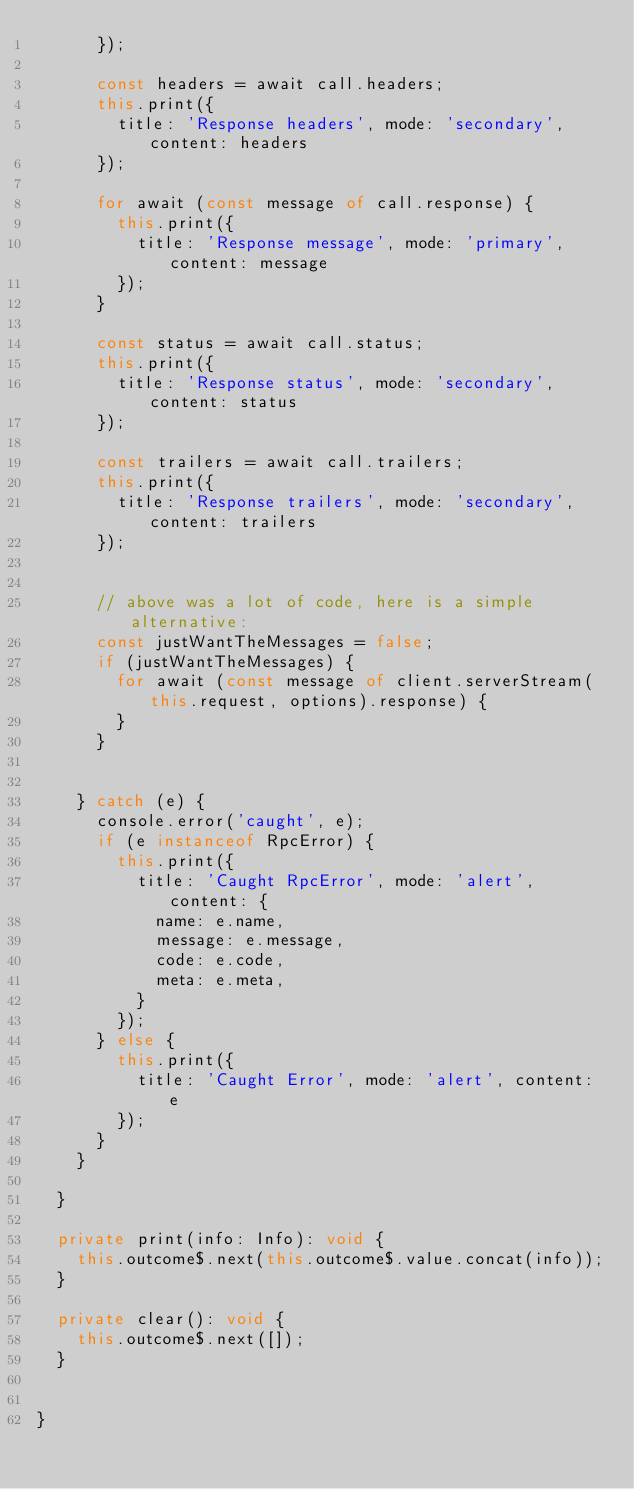<code> <loc_0><loc_0><loc_500><loc_500><_TypeScript_>      });

      const headers = await call.headers;
      this.print({
        title: 'Response headers', mode: 'secondary', content: headers
      });

      for await (const message of call.response) {
        this.print({
          title: 'Response message', mode: 'primary', content: message
        });
      }

      const status = await call.status;
      this.print({
        title: 'Response status', mode: 'secondary', content: status
      });

      const trailers = await call.trailers;
      this.print({
        title: 'Response trailers', mode: 'secondary', content: trailers
      });


      // above was a lot of code, here is a simple alternative:
      const justWantTheMessages = false;
      if (justWantTheMessages) {
        for await (const message of client.serverStream(this.request, options).response) {
        }
      }


    } catch (e) {
      console.error('caught', e);
      if (e instanceof RpcError) {
        this.print({
          title: 'Caught RpcError', mode: 'alert', content: {
            name: e.name,
            message: e.message,
            code: e.code,
            meta: e.meta,
          }
        });
      } else {
        this.print({
          title: 'Caught Error', mode: 'alert', content: e
        });
      }
    }

  }

  private print(info: Info): void {
    this.outcome$.next(this.outcome$.value.concat(info));
  }

  private clear(): void {
    this.outcome$.next([]);
  }


}
</code> 